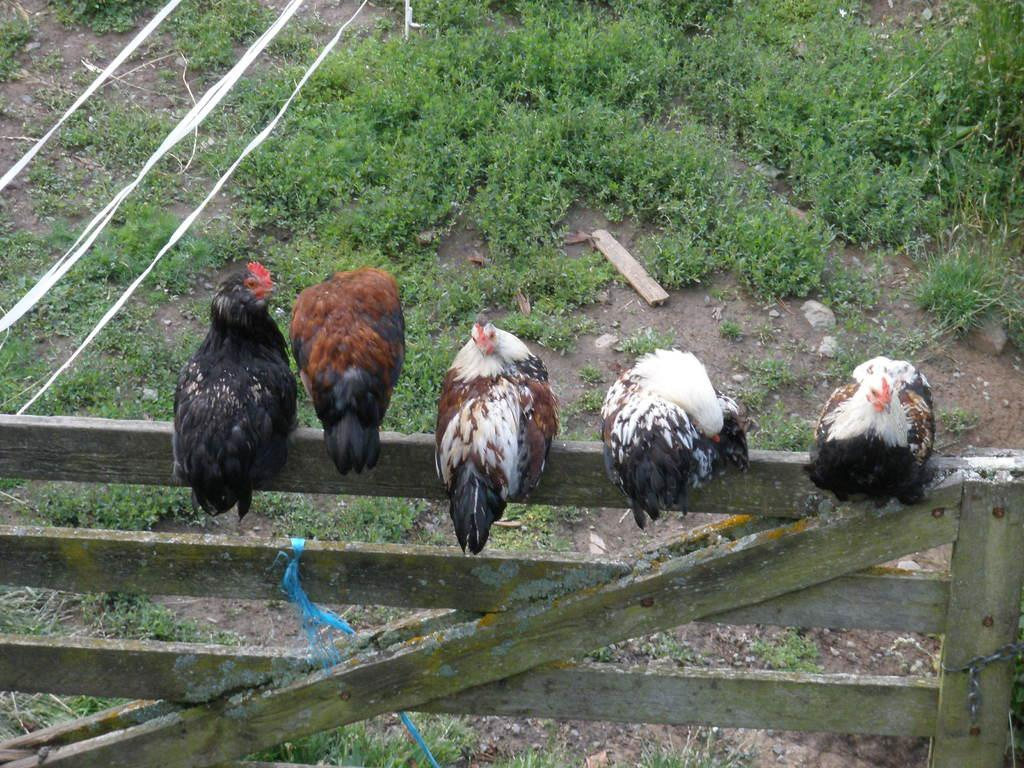What type of animals are in the image? There are hens in the image. Where are the hens located? The hens are sitting on a wooden railing. What can be seen in the background of the image? There are plants in the background of the image. What type of spade is being used by the rabbit in the image? There is no rabbit or spade present in the image; it features hens sitting on a wooden railing with plants in the background. 